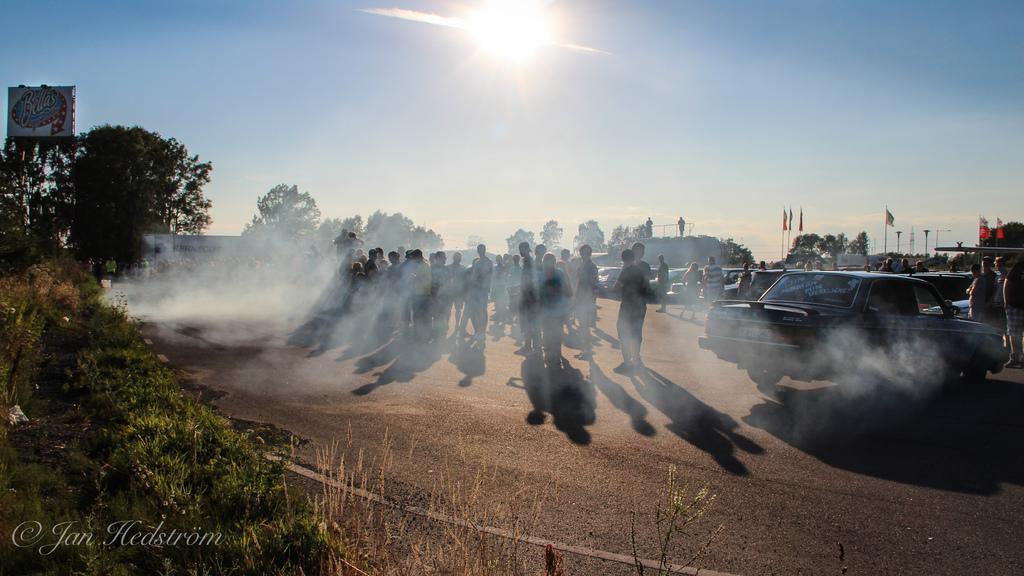Describe this image in one or two sentences. This is an outside view. Here I can see few people are standing on the road. Around these people there are some cars. In the background, I can see some trees and flags. On the left side there are some plants in green color and also I can see a board. On the top of the image I can see the sky along with the sun. On the left bottom of the image I can see some text. 